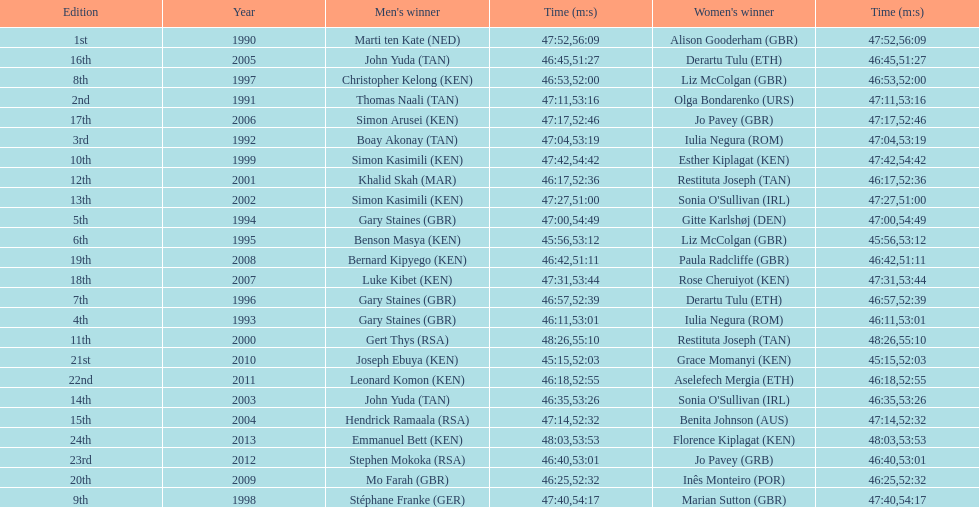Number of men's winners with a finish time under 46:58 12. 